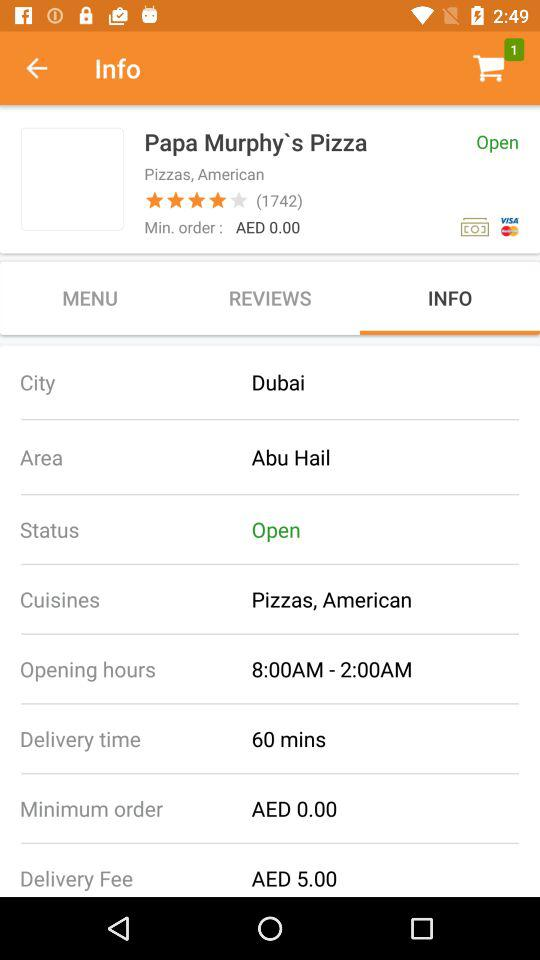What is the name of the restaurant? The name of the restaurant is "Papa Murphy`s Pizza". 